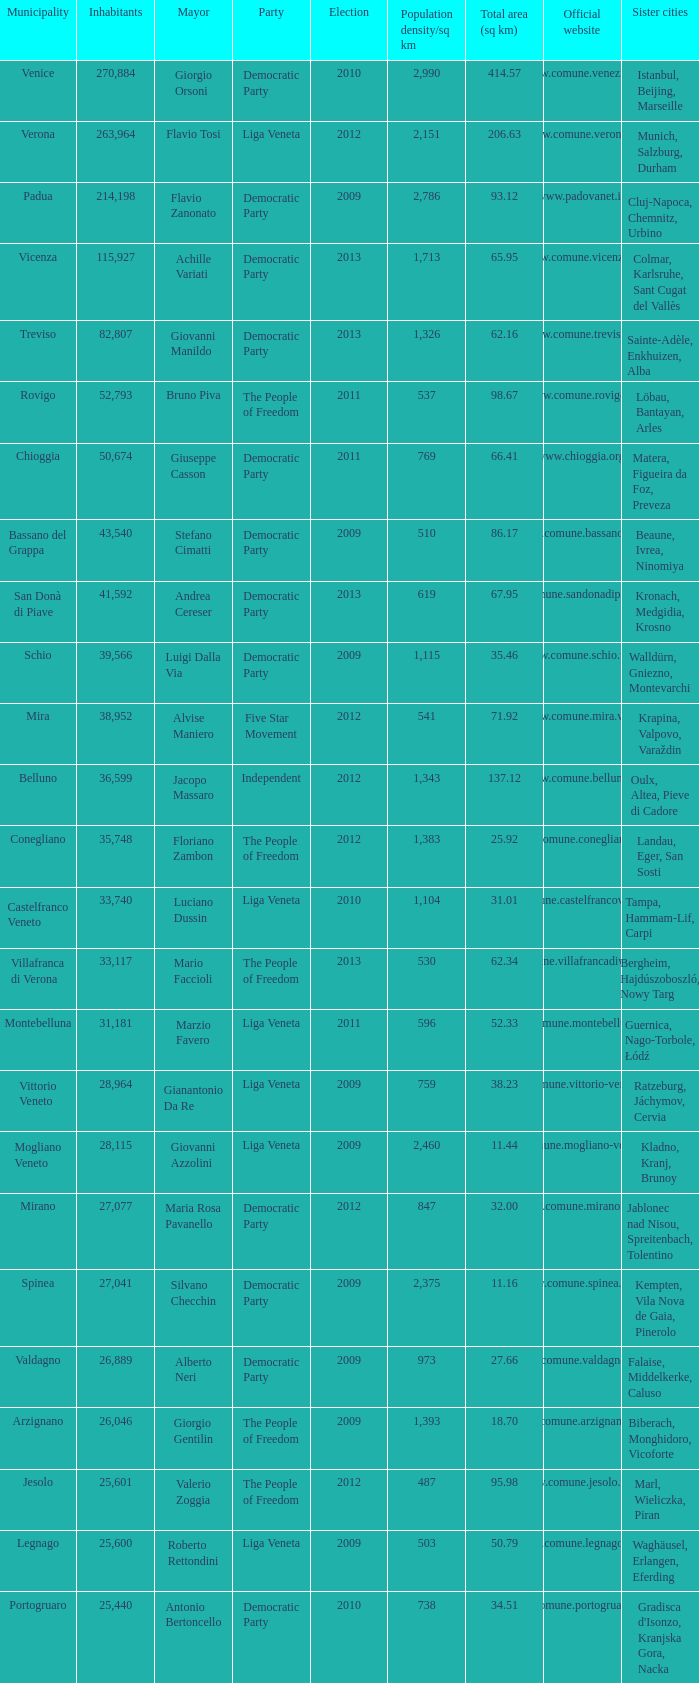What party was achille variati afilliated with? Democratic Party. 